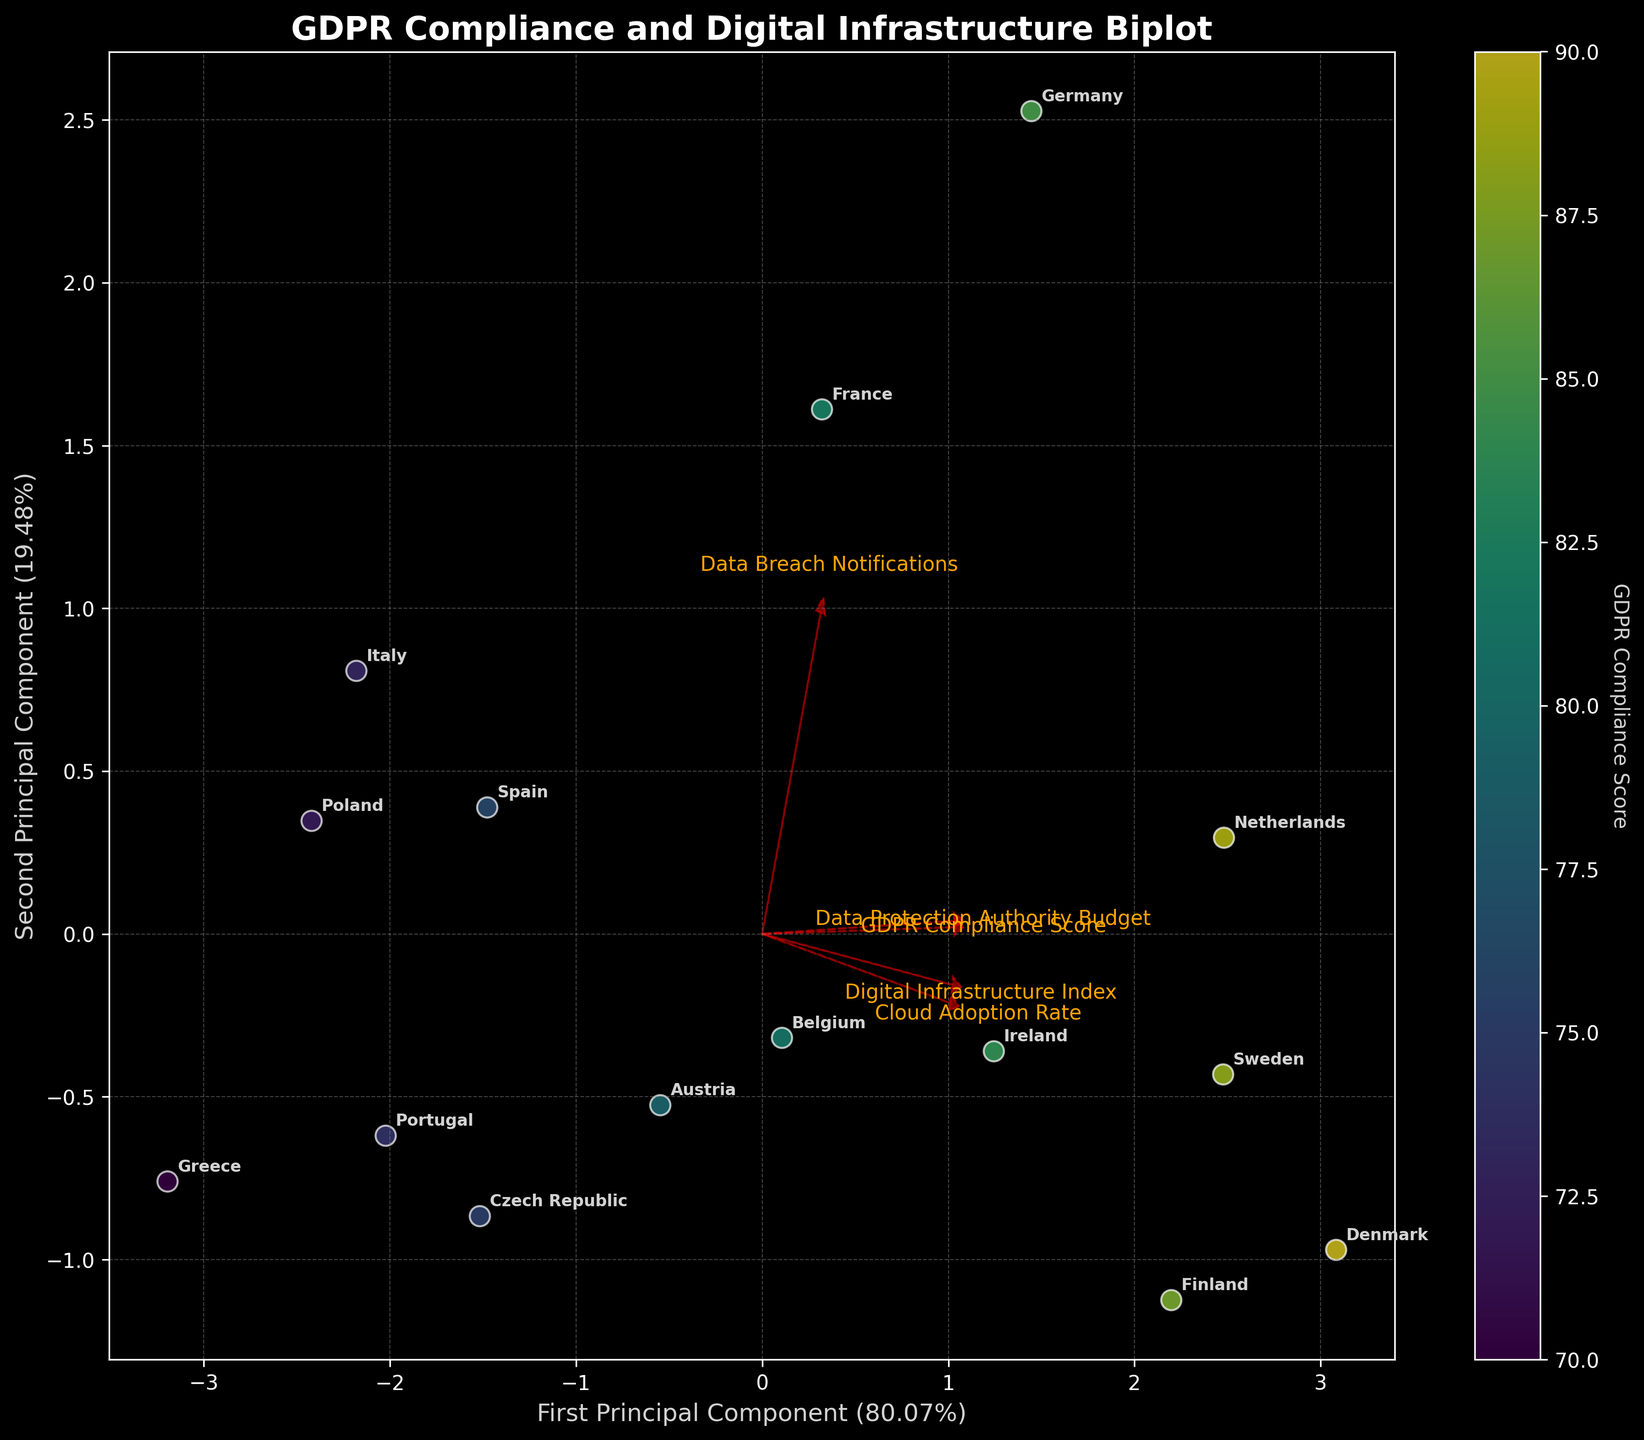What is the title of the figure? The title is displayed prominently at the top of the figure, typically in bold and slightly larger font size.
Answer: GDPR Compliance and Digital Infrastructure Biplot How many countries are plotted in the figure? By counting the labels for each scatter point on the plot, we can determine the number of countries. There should be as many points as there are unique country labels.
Answer: 15 Which country has the highest GDPR Compliance Score as shown by the color gradient? The color gradient represents the GDPR Compliance Score. By checking the scatter points' colors, the country with the deepest color will have the highest score.
Answer: Denmark What percentage of variation is explained by the first Principal Component? The x-axis label will include the percentage of variation explained by the first Principal Component in parentheses.
Answer: 57% What is the relationship between Digital Infrastructure Index and Data Protection Authority Budget as indicated by the biplot vectors? By examining the direction and length of the feature vectors labeled 'Digital Infrastructure Index' and 'Data Protection Authority Budget', we can see if they point in the same direction indicating positive correlation or in opposite directions indicating negative correlation.
Answer: Positive correlation Which country shows the highest Cloud Adoption Rate and where is it located on the plot? The country with the highest Cloud Adoption Rate can be identified by finding the corresponding country label in the feature vector "Cloud Adoption Rate’s” direction.
Answer: Denmark, located far along the direction of the "Cloud Adoption Rate" vector How does the GDPR Compliance Score correlate with the first principal component? We need to look at the "GDPR Compliance Score" vector and see its alignment and length relative to the first principal component (x-axis) to understand the correlation.
Answer: Strong correlation; as the GDPR Compliance Score vector points in the same direction as the first principal component Which two countries have the closest GDPR Compliance Scores? By examining the colors of the scatter points, two countries with very similar colors will be close in GDPR Compliance Scores. Hum an inspection can pinpoint the two countries.
Answer: Spain and Portugal Are higher GDPR Compliance Scores associated with higher Data Breach Notifications? Explain the reasoning with reference to biplot vectors. Assess the vectors associated with "GDPR Compliance Score" and "Data Breach Notifications" if they point in similar directions and have similar lengths.
Answer: No, the vectors point in somewhat different directions indicating a weak or no strong association Which country has both a low GDPR Compliance Score and a low Digital Infrastructure Index? By locating countries situated on the negative side of both the "GDPR Compliance Score" and "Digital Infrastructure Index" vectors (bottom-left quadrant), we can find the country that meets both criteria.
Answer: Greece 